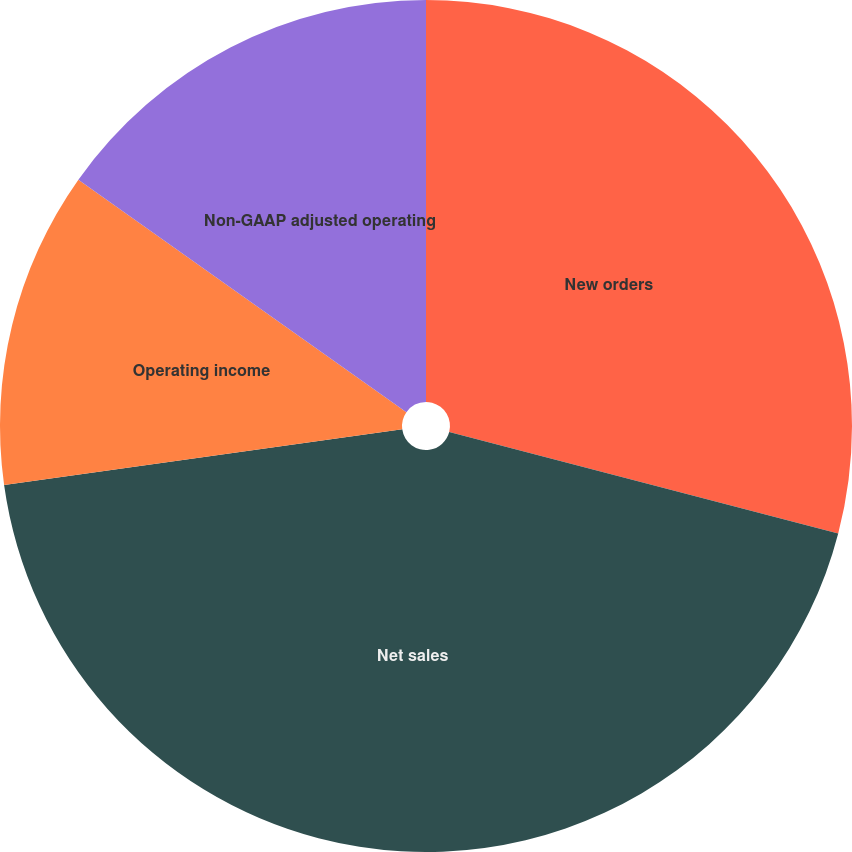Convert chart to OTSL. <chart><loc_0><loc_0><loc_500><loc_500><pie_chart><fcel>New orders<fcel>Net sales<fcel>Operating income<fcel>Non-GAAP adjusted operating<nl><fcel>29.06%<fcel>43.73%<fcel>12.02%<fcel>15.19%<nl></chart> 